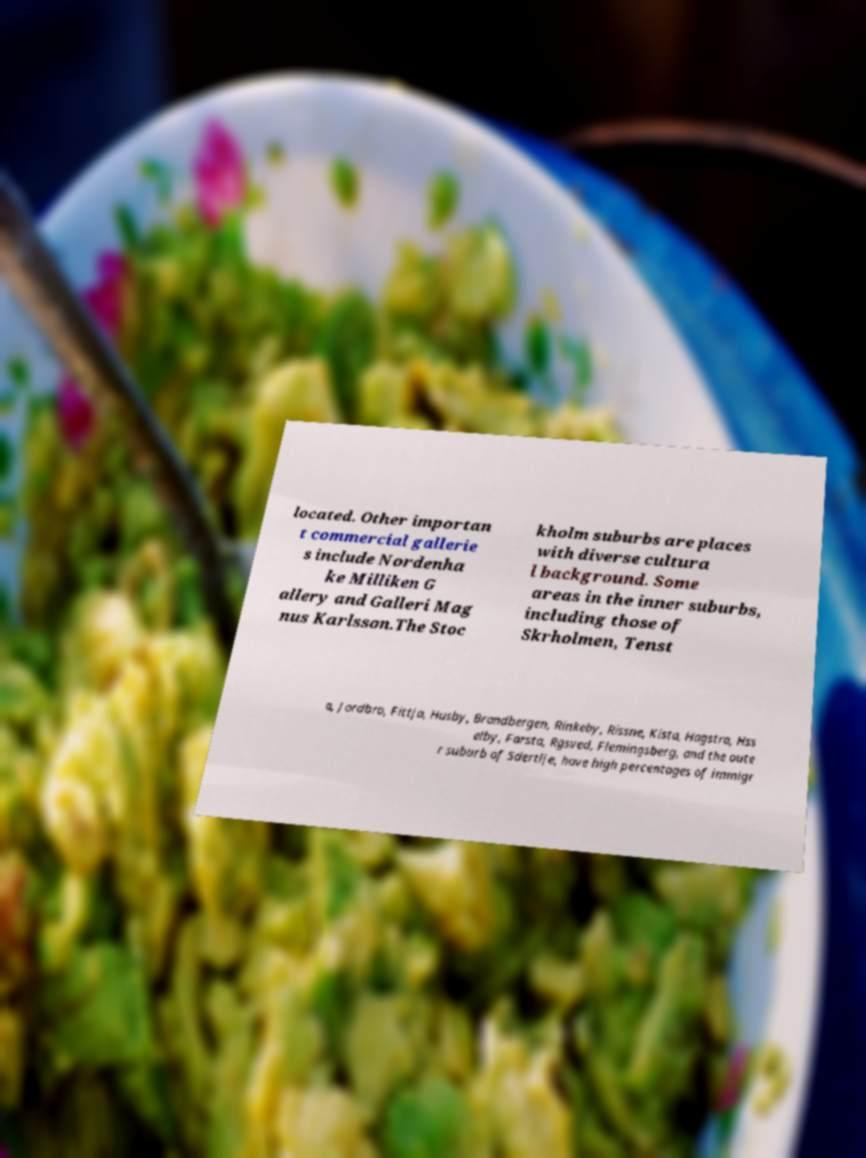Could you extract and type out the text from this image? located. Other importan t commercial gallerie s include Nordenha ke Milliken G allery and Galleri Mag nus Karlsson.The Stoc kholm suburbs are places with diverse cultura l background. Some areas in the inner suburbs, including those of Skrholmen, Tenst a, Jordbro, Fittja, Husby, Brandbergen, Rinkeby, Rissne, Kista, Hagstra, Hss elby, Farsta, Rgsved, Flemingsberg, and the oute r suburb of Sdertlje, have high percentages of immigr 